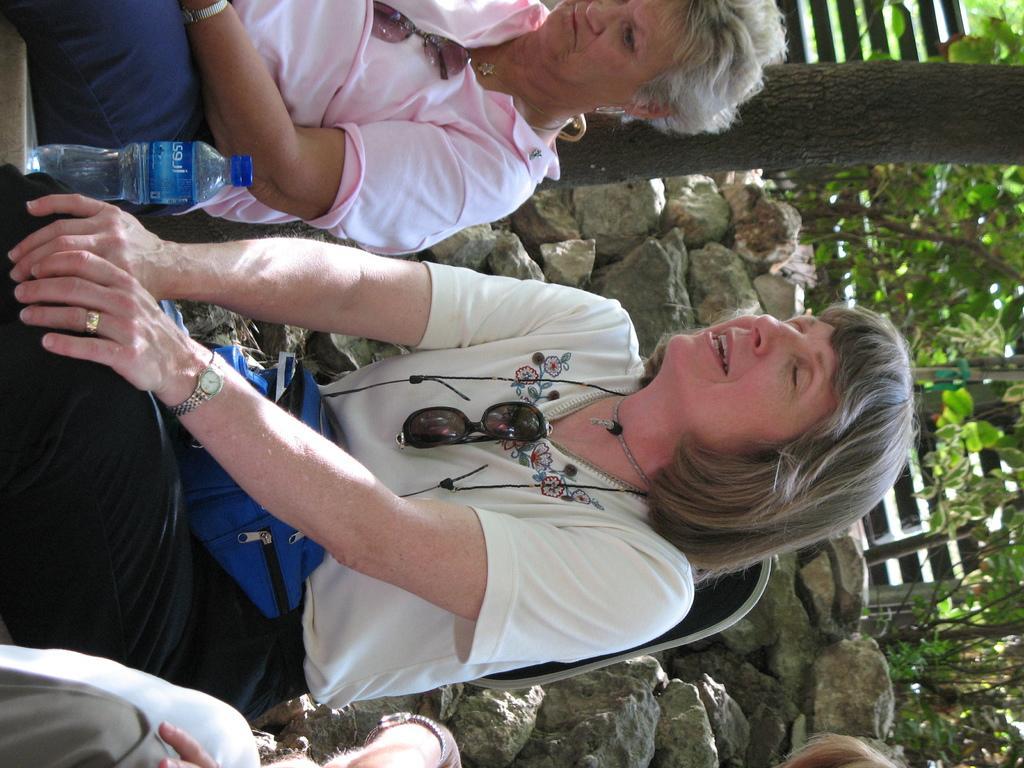In one or two sentences, can you explain what this image depicts? In this image we can see people sitting and there is a bottle. In the background there are rocks, trees and a fence. 